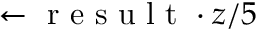Convert formula to latex. <formula><loc_0><loc_0><loc_500><loc_500>\leftarrow r e s u l t \cdot z / 5</formula> 